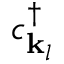Convert formula to latex. <formula><loc_0><loc_0><loc_500><loc_500>c _ { { k } _ { l } } ^ { \dagger }</formula> 